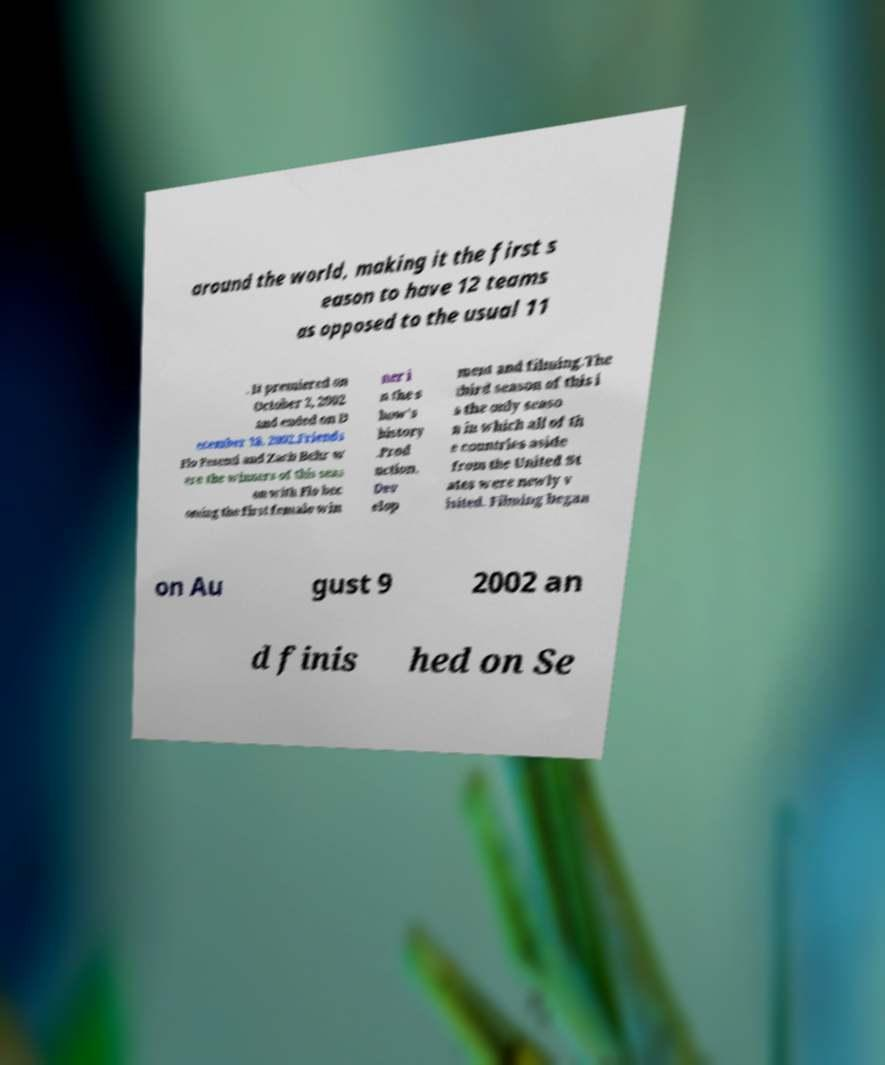Can you read and provide the text displayed in the image?This photo seems to have some interesting text. Can you extract and type it out for me? around the world, making it the first s eason to have 12 teams as opposed to the usual 11 . It premiered on October 2, 2002 and ended on D ecember 18, 2002.Friends Flo Pesenti and Zach Behr w ere the winners of this seas on with Flo bec oming the first female win ner i n the s how's history .Prod uction. Dev elop ment and filming.The third season of this i s the only seaso n in which all of th e countries aside from the United St ates were newly v isited. Filming began on Au gust 9 2002 an d finis hed on Se 